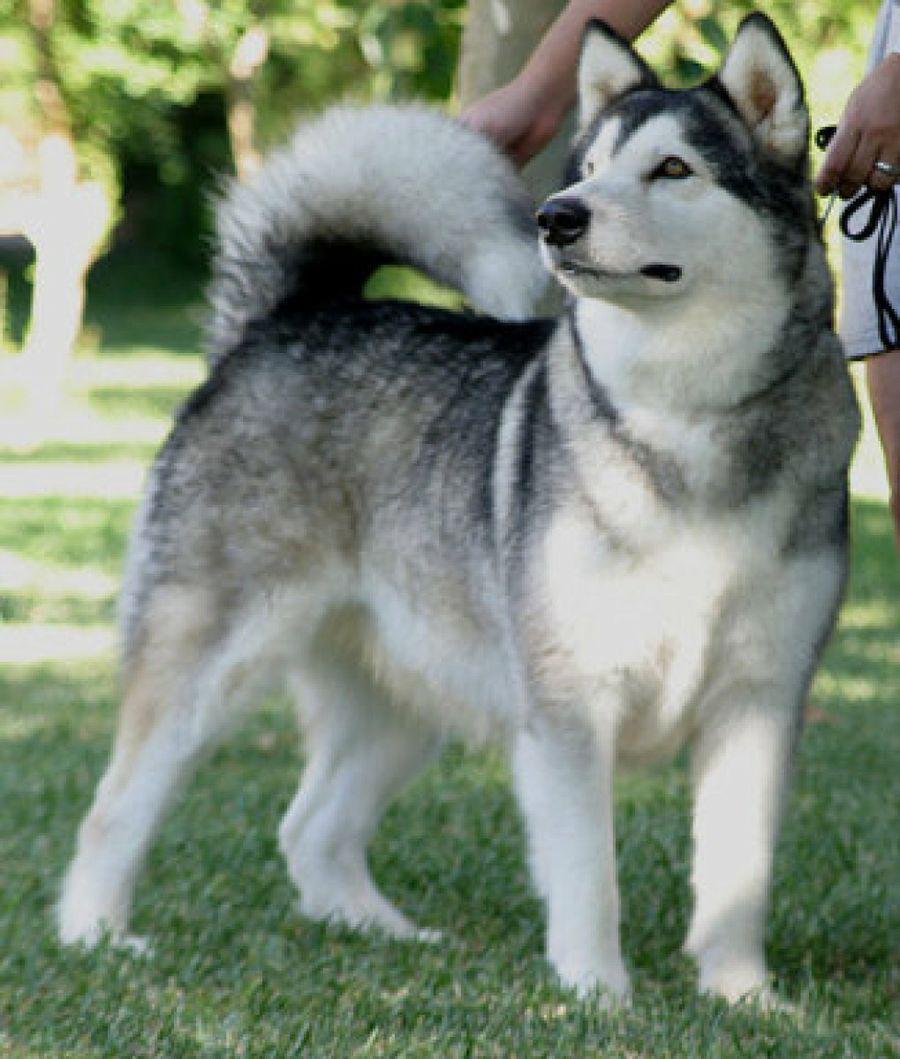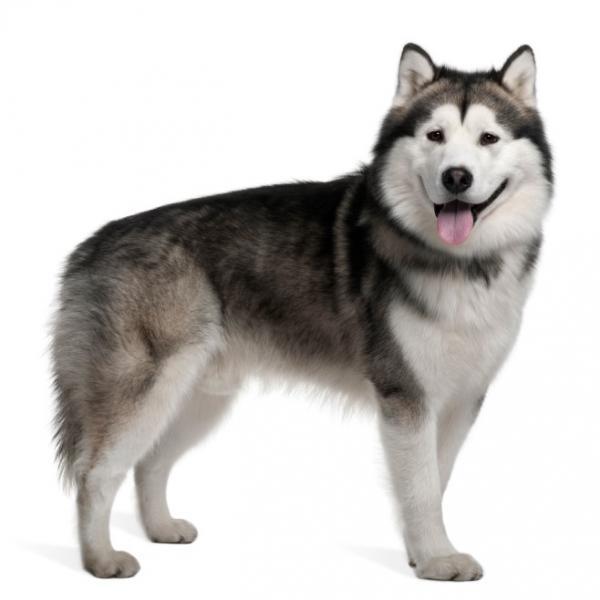The first image is the image on the left, the second image is the image on the right. For the images displayed, is the sentence "The left and right image contains a total of three dogs with at least two in the snow." factually correct? Answer yes or no. No. The first image is the image on the left, the second image is the image on the right. For the images shown, is this caption "The right image contains one dog, who is looking at the camera with a smiling face and his tongue hanging down past his chin." true? Answer yes or no. Yes. 